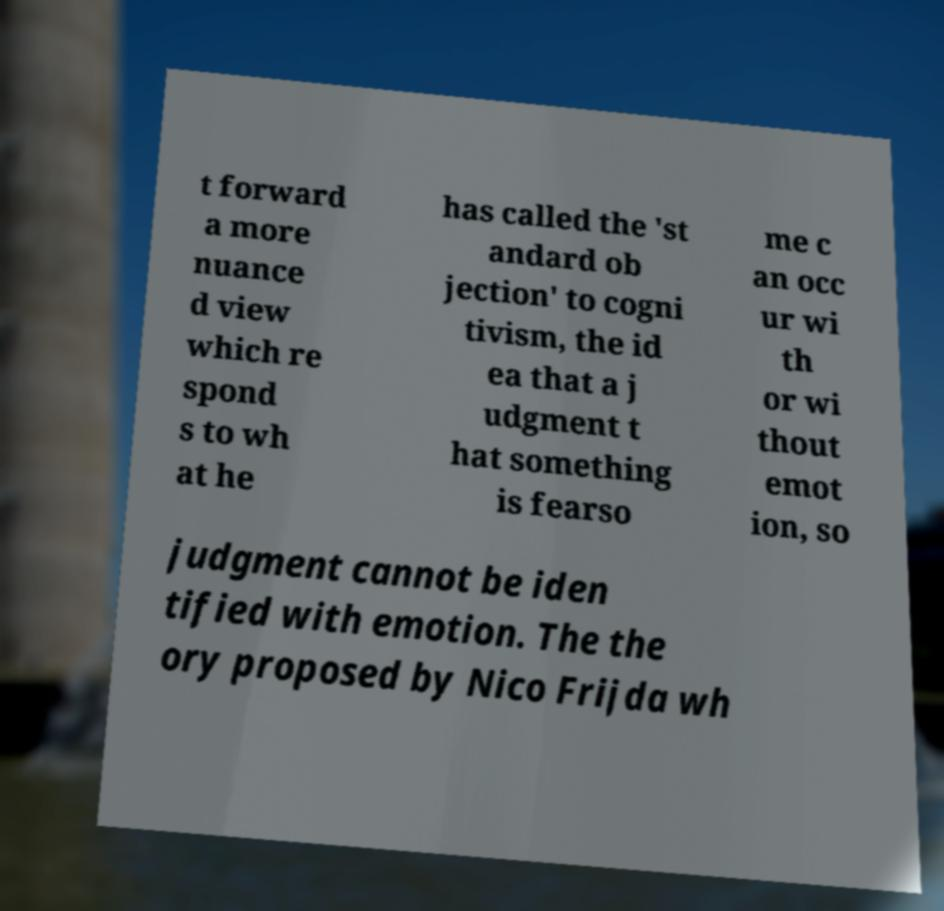Please read and relay the text visible in this image. What does it say? t forward a more nuance d view which re spond s to wh at he has called the 'st andard ob jection' to cogni tivism, the id ea that a j udgment t hat something is fearso me c an occ ur wi th or wi thout emot ion, so judgment cannot be iden tified with emotion. The the ory proposed by Nico Frijda wh 